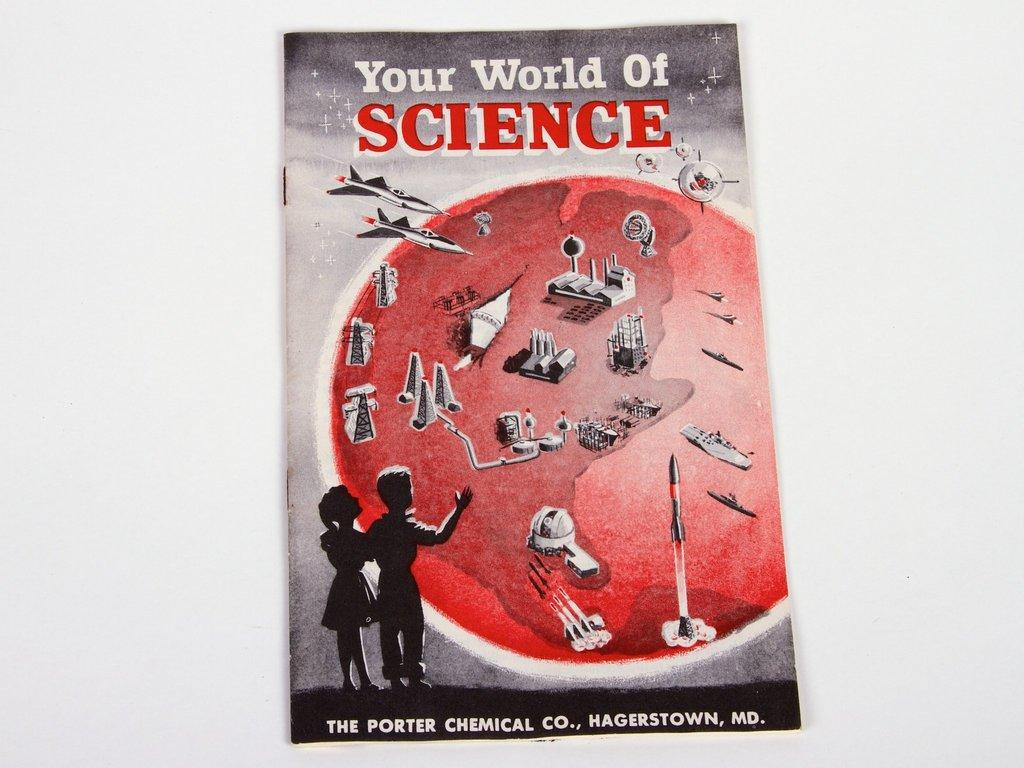What is the main subject of the image? The main subject of the image is a cover page. What can be found on the cover page? The cover page contains text. Is there a drain visible on the cover page in the image? No, there is no drain present on the cover page in the image. 